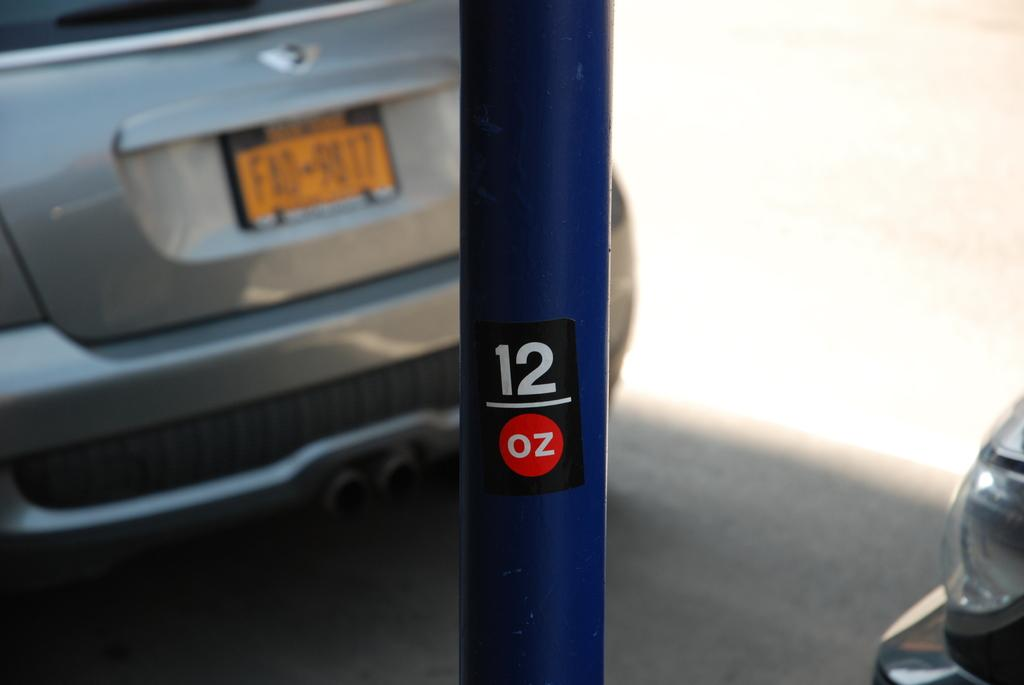What is the main object in the middle of the image? There is a pole in the middle of the image. What is written or displayed on the pole? There is text on the pole. Can you describe the vehicles in the image? There is a car parked on the left side of the road, and another car is on the right side of the road. What type of vessel is sailing on the trail in the image? There is no vessel or trail present in the image; it features a pole with text and two cars on the road. 